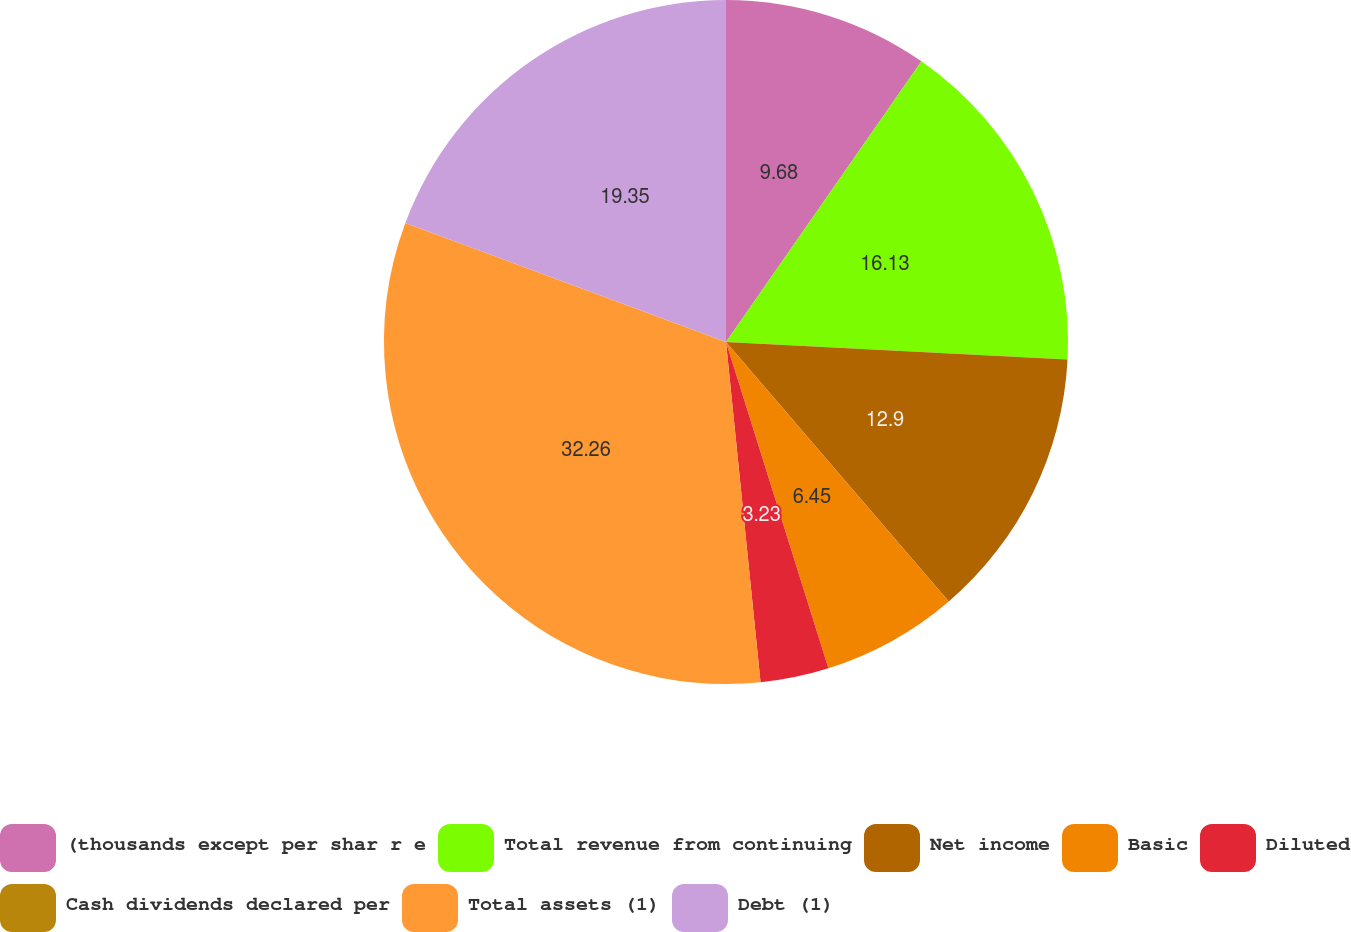Convert chart to OTSL. <chart><loc_0><loc_0><loc_500><loc_500><pie_chart><fcel>(thousands except per shar r e<fcel>Total revenue from continuing<fcel>Net income<fcel>Basic<fcel>Diluted<fcel>Cash dividends declared per<fcel>Total assets (1)<fcel>Debt (1)<nl><fcel>9.68%<fcel>16.13%<fcel>12.9%<fcel>6.45%<fcel>3.23%<fcel>0.0%<fcel>32.26%<fcel>19.35%<nl></chart> 